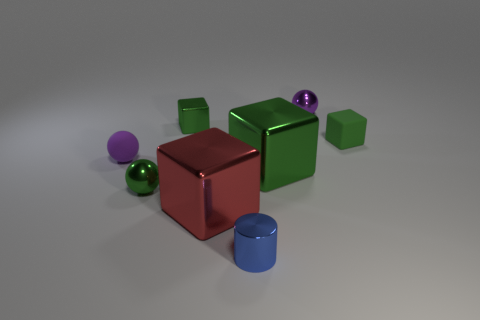Are there more large cyan cylinders than matte cubes?
Provide a short and direct response. No. What number of objects are tiny blocks left of the big green object or small spheres that are to the left of the tiny purple metallic object?
Your response must be concise. 3. What is the color of the metallic cylinder that is the same size as the green sphere?
Provide a short and direct response. Blue. Is the material of the tiny blue object the same as the green ball?
Your answer should be very brief. Yes. There is a tiny purple object to the right of the big block right of the red metallic thing; what is it made of?
Provide a succinct answer. Metal. Are there more small metallic balls to the left of the tiny blue shiny cylinder than big gray matte objects?
Give a very brief answer. Yes. What number of other objects are the same size as the purple metallic ball?
Your answer should be compact. 5. Is the small metallic block the same color as the matte block?
Your answer should be very brief. Yes. There is a small rubber object left of the metal sphere that is to the right of the object in front of the large red shiny thing; what is its color?
Make the answer very short. Purple. How many big blocks are behind the metal sphere in front of the purple thing to the right of the red shiny thing?
Your answer should be very brief. 1. 